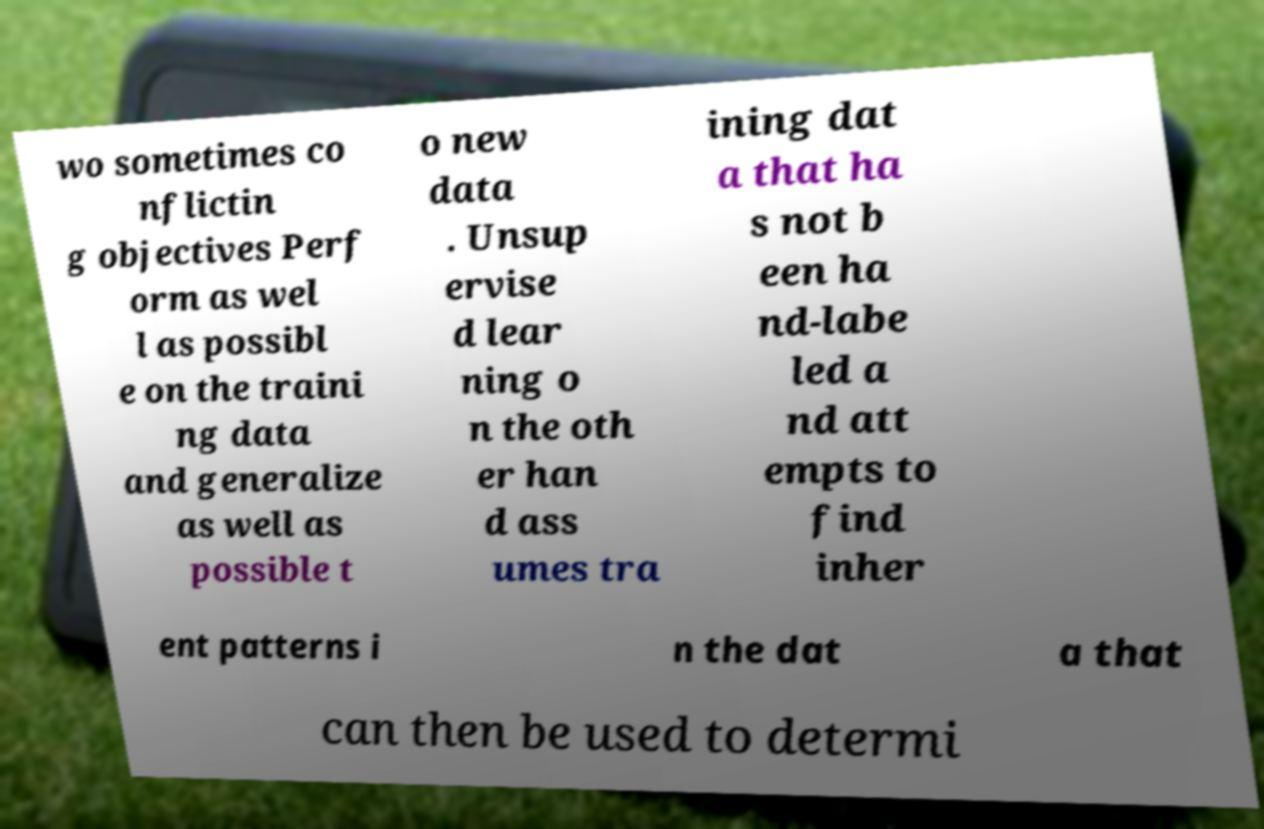Could you assist in decoding the text presented in this image and type it out clearly? wo sometimes co nflictin g objectives Perf orm as wel l as possibl e on the traini ng data and generalize as well as possible t o new data . Unsup ervise d lear ning o n the oth er han d ass umes tra ining dat a that ha s not b een ha nd-labe led a nd att empts to find inher ent patterns i n the dat a that can then be used to determi 